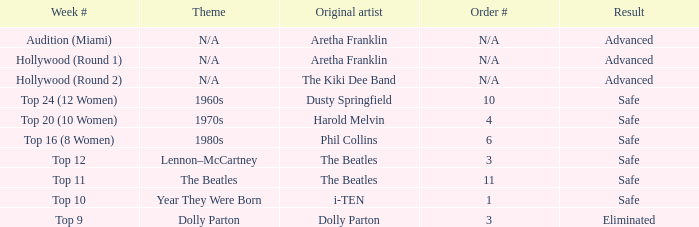What is the original artist that has 11 as the order number? The Beatles. 